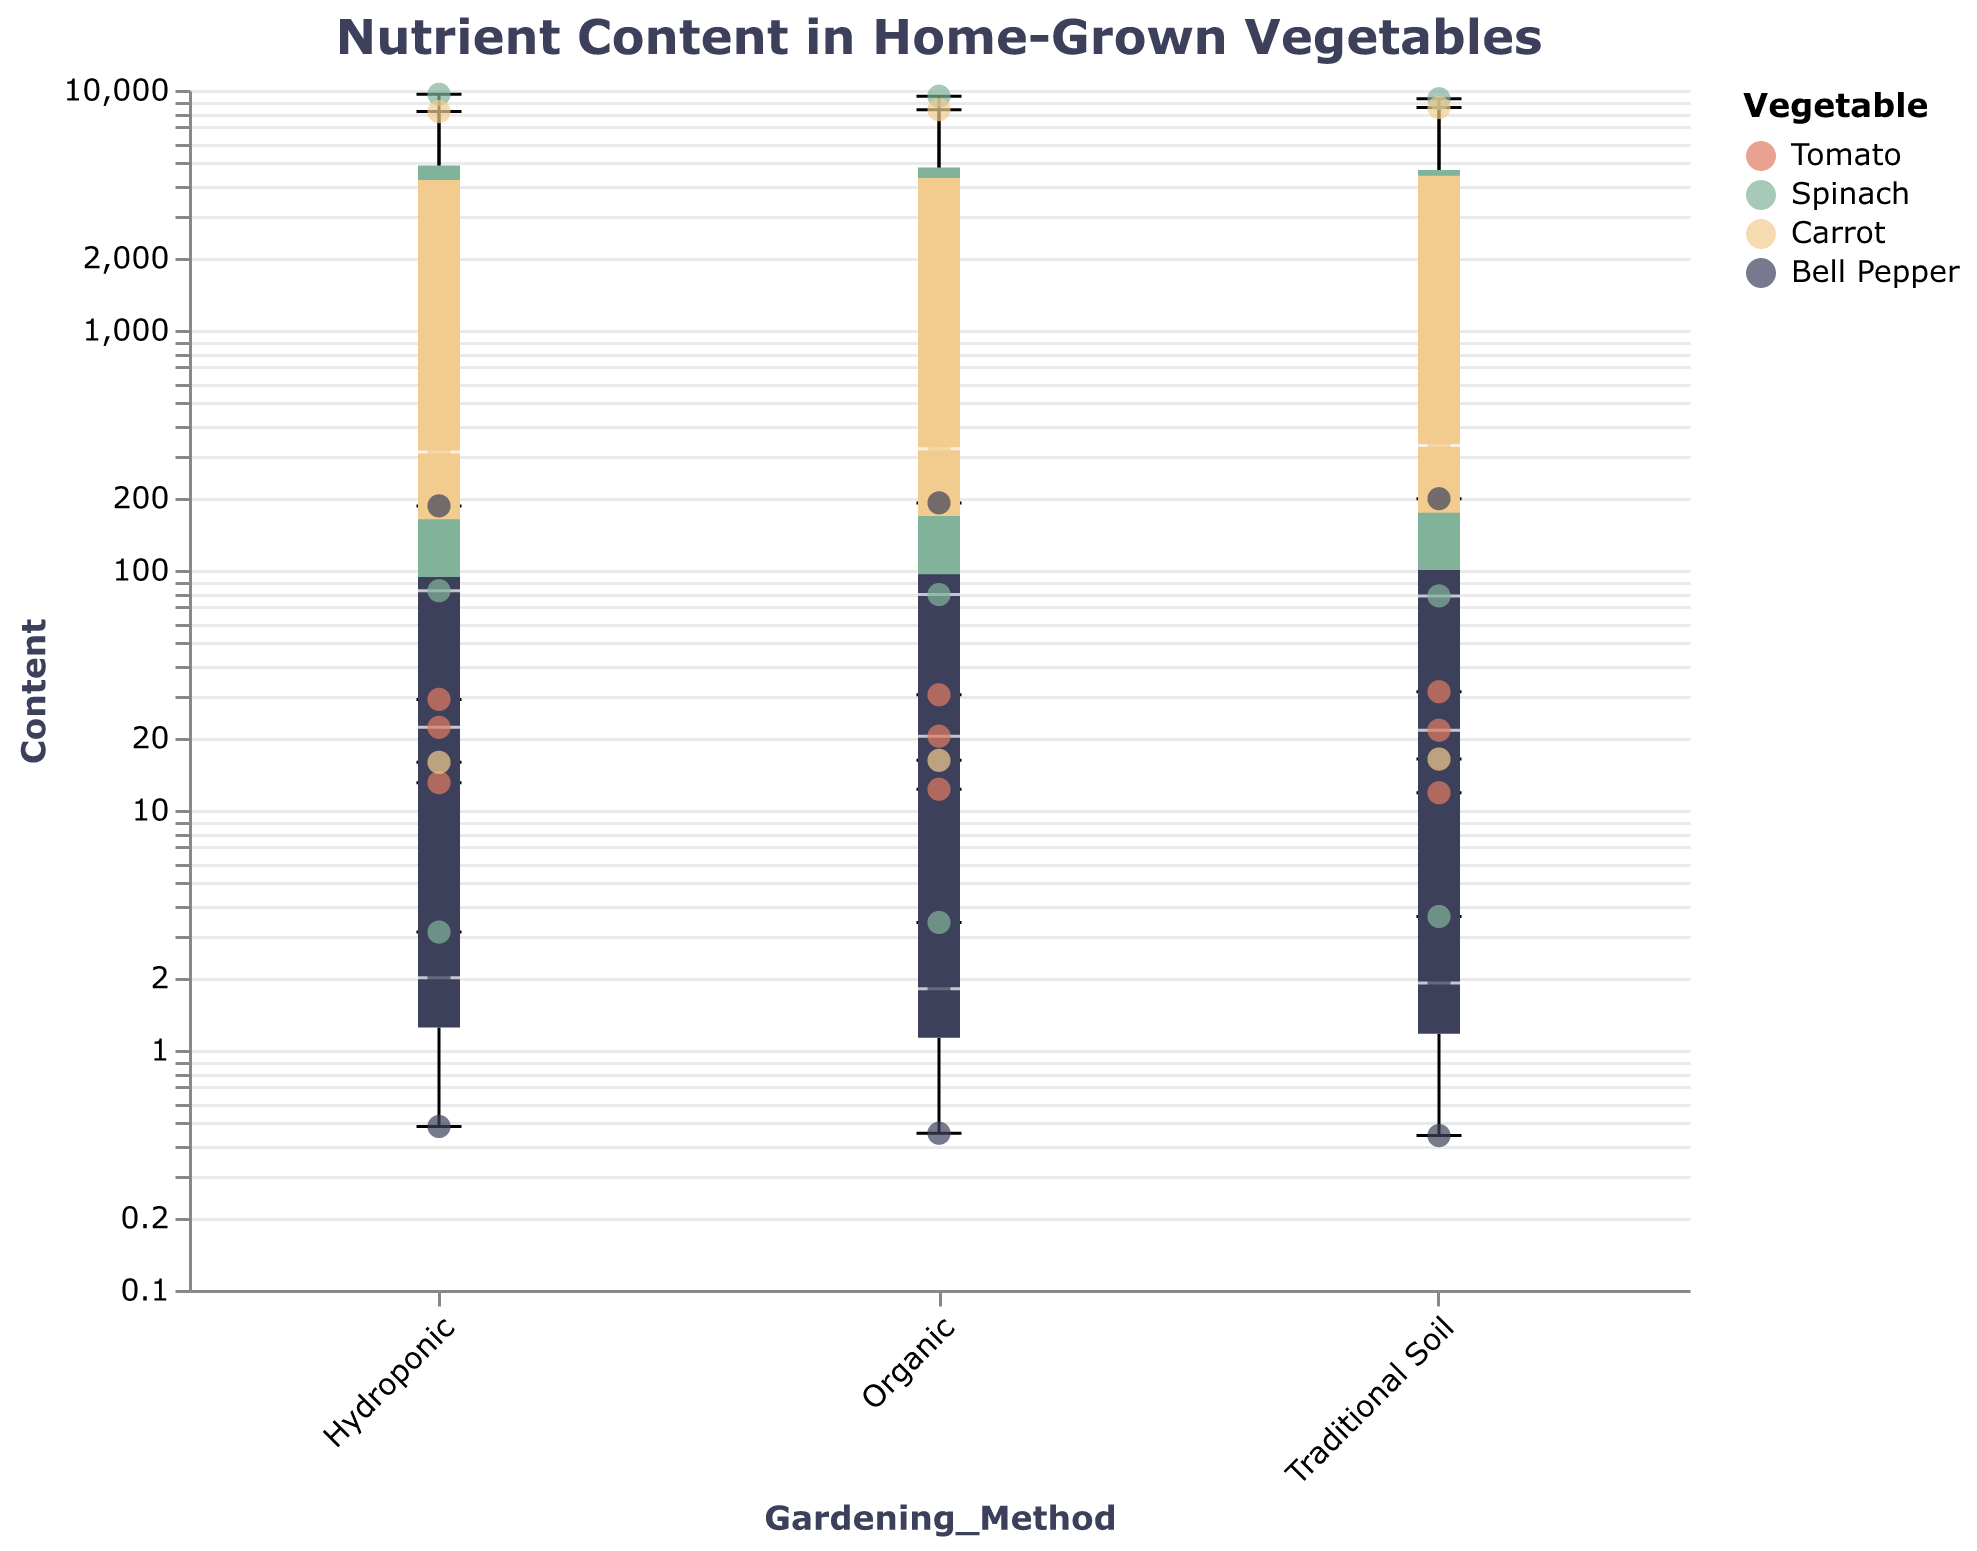What is the range of Lycopene content in Tomatoes grown using Traditional Soil? Look at the scatter points and the box plot for "Tomato" under "Traditional Soil," and identify the minimum and maximum values. For Lycopene, the values are 31.1 (upper point) and 31.1 (lower point) as they are the same.
Answer: 31.1 Which vegetable shows the highest content of Vitamin C using Hydroponic gardening? Check the scatter points for Vitamin C across all vegetables under "Hydroponic." Bell Pepper shows the highest scatter point (185.0) indicating the highest Vitamin C content.
Answer: Bell Pepper Compare the median level of Beta Carotene in Organic versus Hydroponic Carrots. Which one is higher? Compare the positions of the medians of box plots for Beta Carotene in "Organic" and "Hydroponic" under Carrot. "Organic" has a median around 8280 and "Hydroponic" around 8130.
Answer: Organic What is the interquartile range (IQR) for Iron in Organic Spinach? Find the first quartile (lower edge of the box) and the third quartile (upper edge of the box) for Iron content in Organic Spinach. The range is from 3.4 to 3.4 (since it's a single value it seems). IQR = 3.4 - 3.4 = 0.
Answer: 0 Which gardening method produced the highest scatter point of Vitamin A in Spinach? Look at the scatter points for Vitamin A across all gardening methods for Spinach. The highest scatter point is 9600 visible under "Hydroponic."
Answer: Hydroponic How does the Vitamin E content in Bell Peppers compare between Organic and Traditional Soil methods? Check the scatter points for Vitamin E in Bell Peppers under "Organic" and "Traditional Soil." "Organic" has 1.8 and "Traditional Soil" has 1.9.
Answer: Traditional Soil For Carrot, which gardening method has the highest median content of Potassium? Compare the medians for Potassium in Carrot across all methods (box plots). "Traditional Soil" appears to have the highest median Potassium content.
Answer: Traditional Soil Calculate the average Lycopene content in Tomatoes across all gardening methods. Which method has the highest average? Average the Lycopene values across "Organic" (30.2), "Hydroponic" (28.9), and "Traditional Soil" (31.1). Organic average: (30.2 + 31.1 + 28.9) / 3 = 30.07.
Answer: Traditional Soil Identify the nutrient with the largest difference in median values between two gardening methods within any vegetable group. Find the biggest difference in any nutrient's median level across gardening methods for any vegetable. The median for Beta Carotene in Carrots shows a notable difference between Traditional Soil (8450) and Hydroponic (8130): 8450 - 8130.
Answer: Beta Carotene in Carrots 